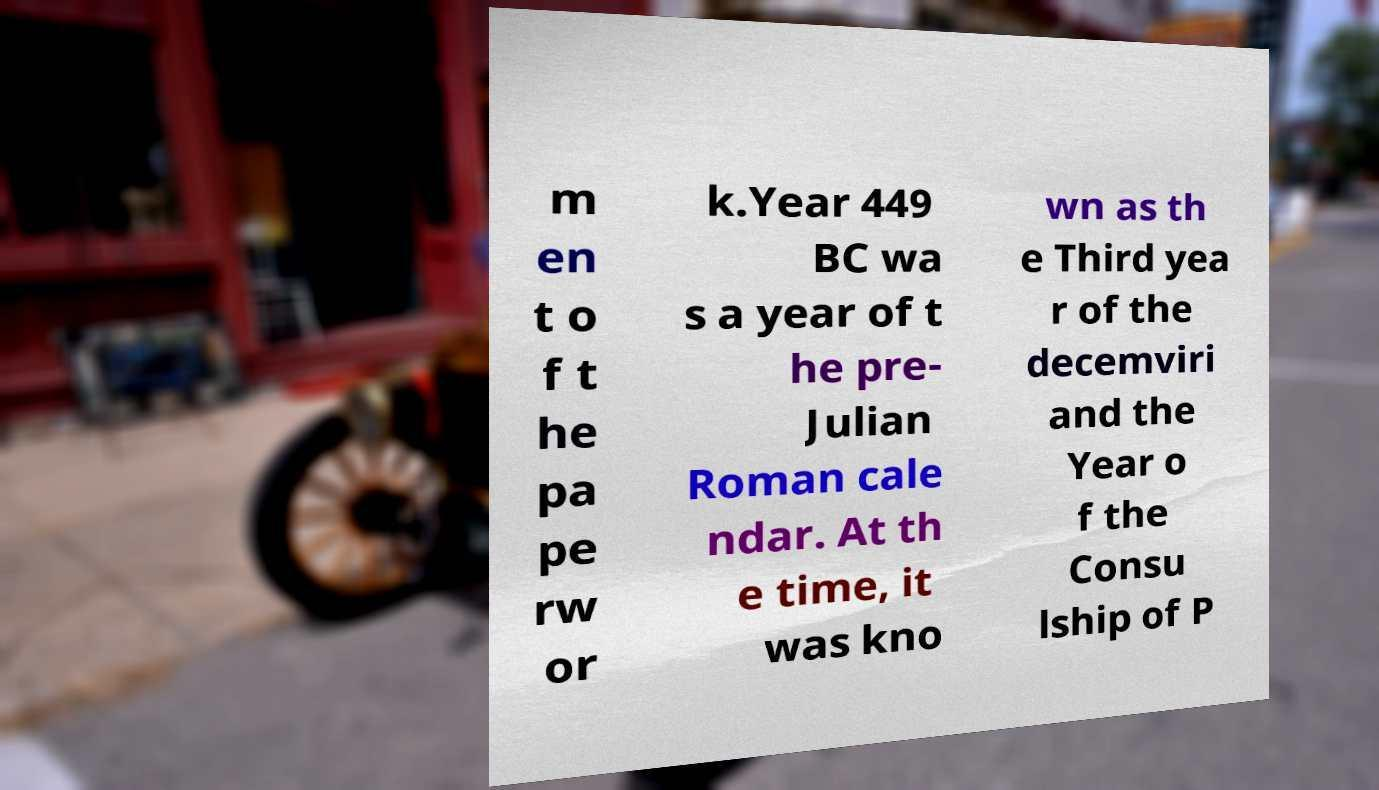There's text embedded in this image that I need extracted. Can you transcribe it verbatim? m en t o f t he pa pe rw or k.Year 449 BC wa s a year of t he pre- Julian Roman cale ndar. At th e time, it was kno wn as th e Third yea r of the decemviri and the Year o f the Consu lship of P 